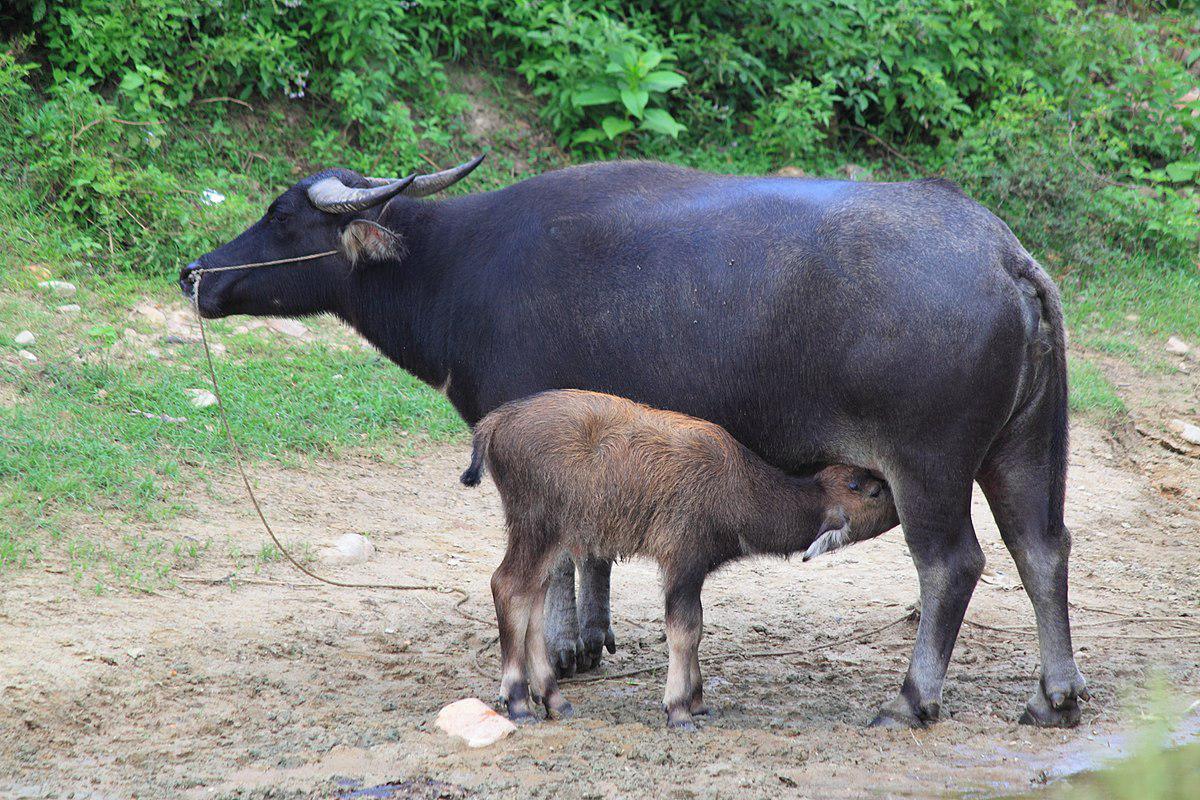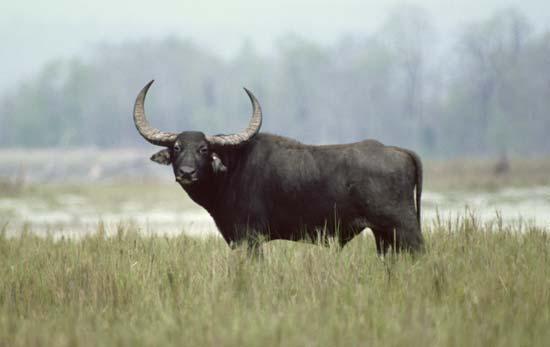The first image is the image on the left, the second image is the image on the right. Considering the images on both sides, is "In the left image, one horned animal looks directly at the camera." valid? Answer yes or no. No. The first image is the image on the left, the second image is the image on the right. For the images shown, is this caption "In one image, animals are standing in water beside a grassy area." true? Answer yes or no. No. 